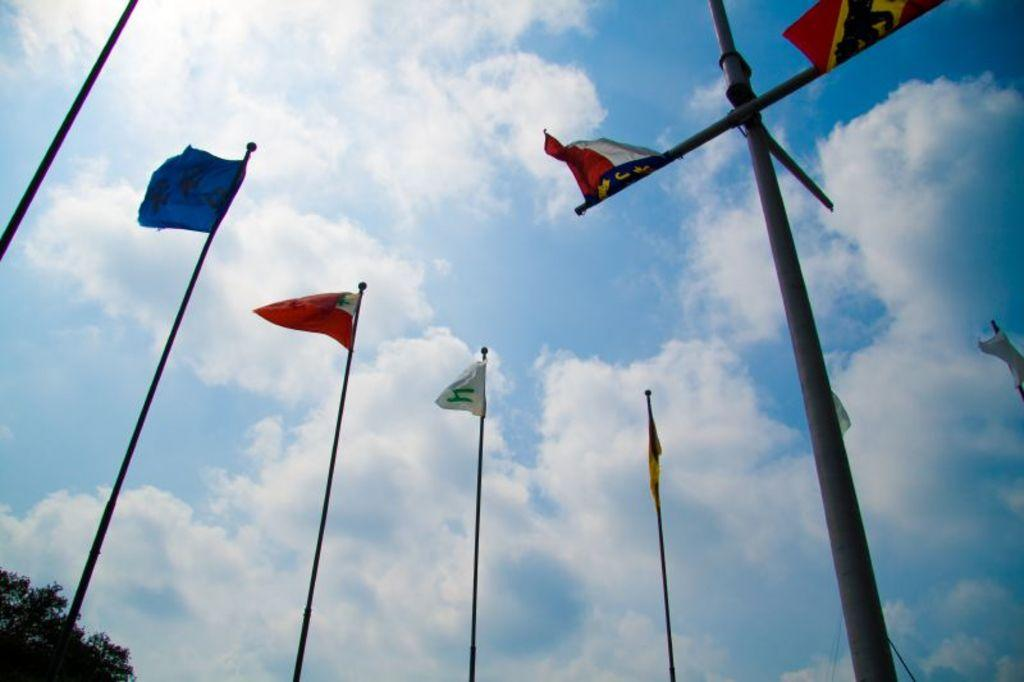What is located in the bottom left corner of the image? There is a tree in the bottom left corner of the image. What can be seen in the middle of the image? There are poles in the middle of the image. What is attached to the poles? There are flags on the poles. What is visible in the sky in the image? There are clouds visible in the sky. How many chickens are perched on the tree in the image? There are no chickens present in the image; it features a tree, poles, flags, and clouds. Who is the expert in the image? There is no expert present in the image. 